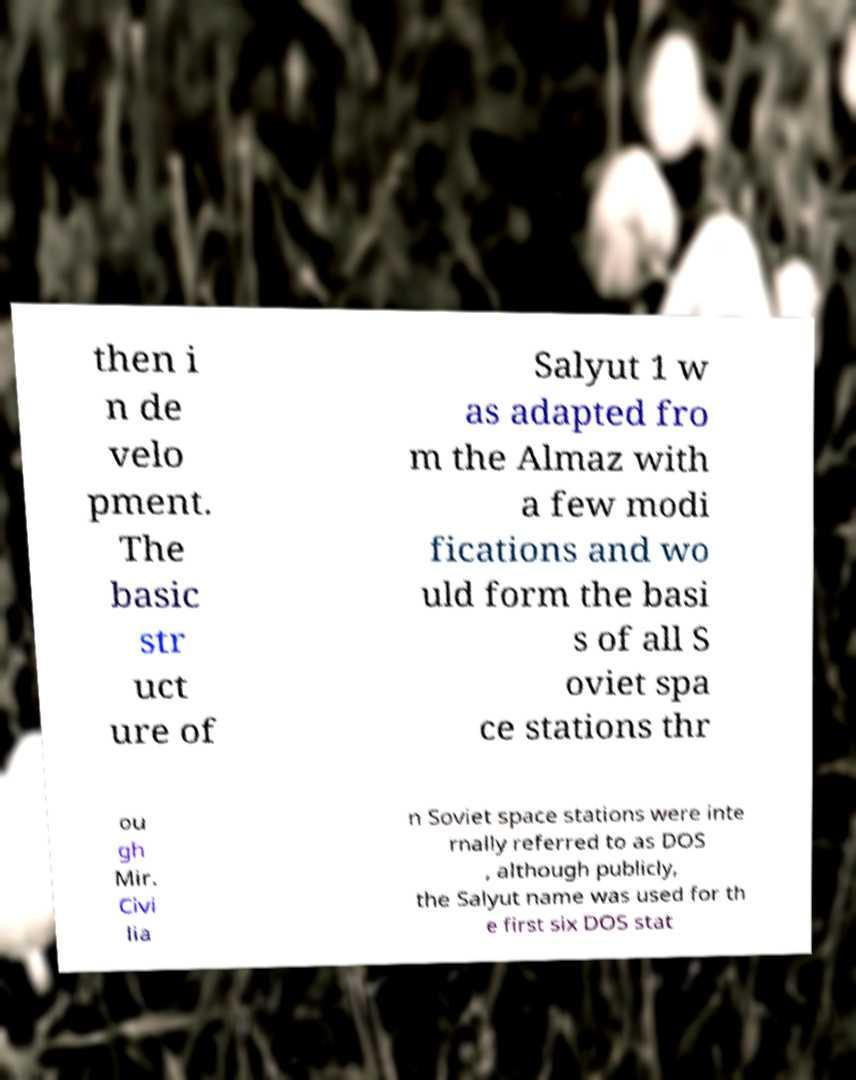Please read and relay the text visible in this image. What does it say? then i n de velo pment. The basic str uct ure of Salyut 1 w as adapted fro m the Almaz with a few modi fications and wo uld form the basi s of all S oviet spa ce stations thr ou gh Mir. Civi lia n Soviet space stations were inte rnally referred to as DOS , although publicly, the Salyut name was used for th e first six DOS stat 